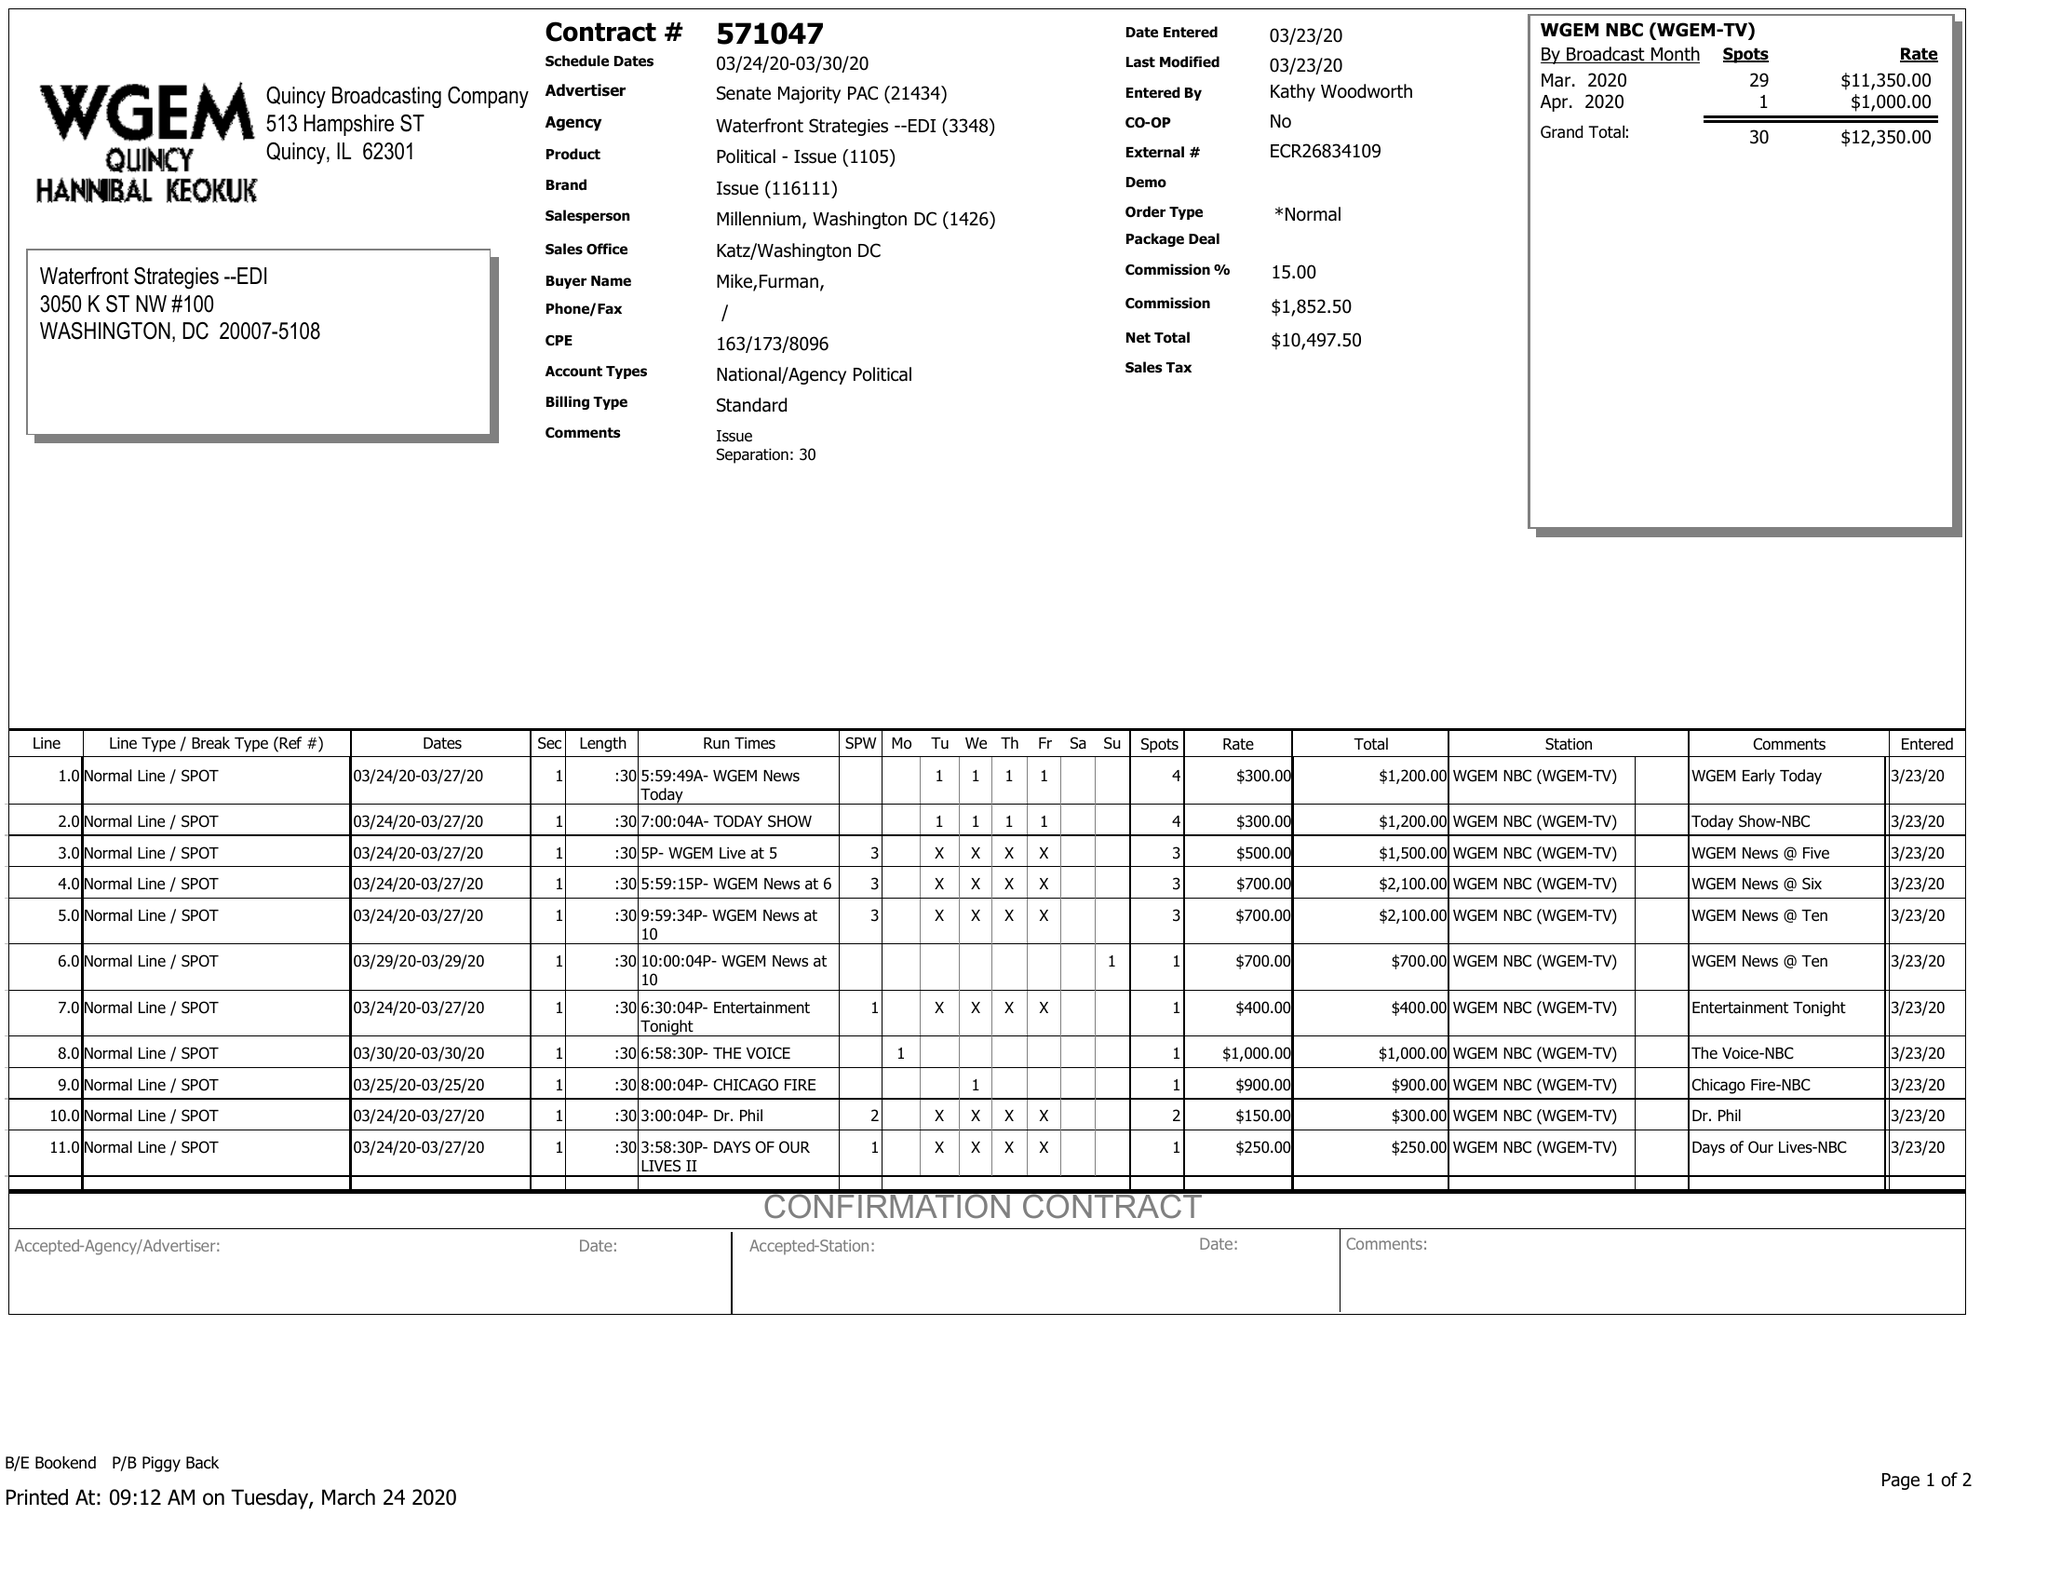What is the value for the flight_from?
Answer the question using a single word or phrase. 03/24/20 